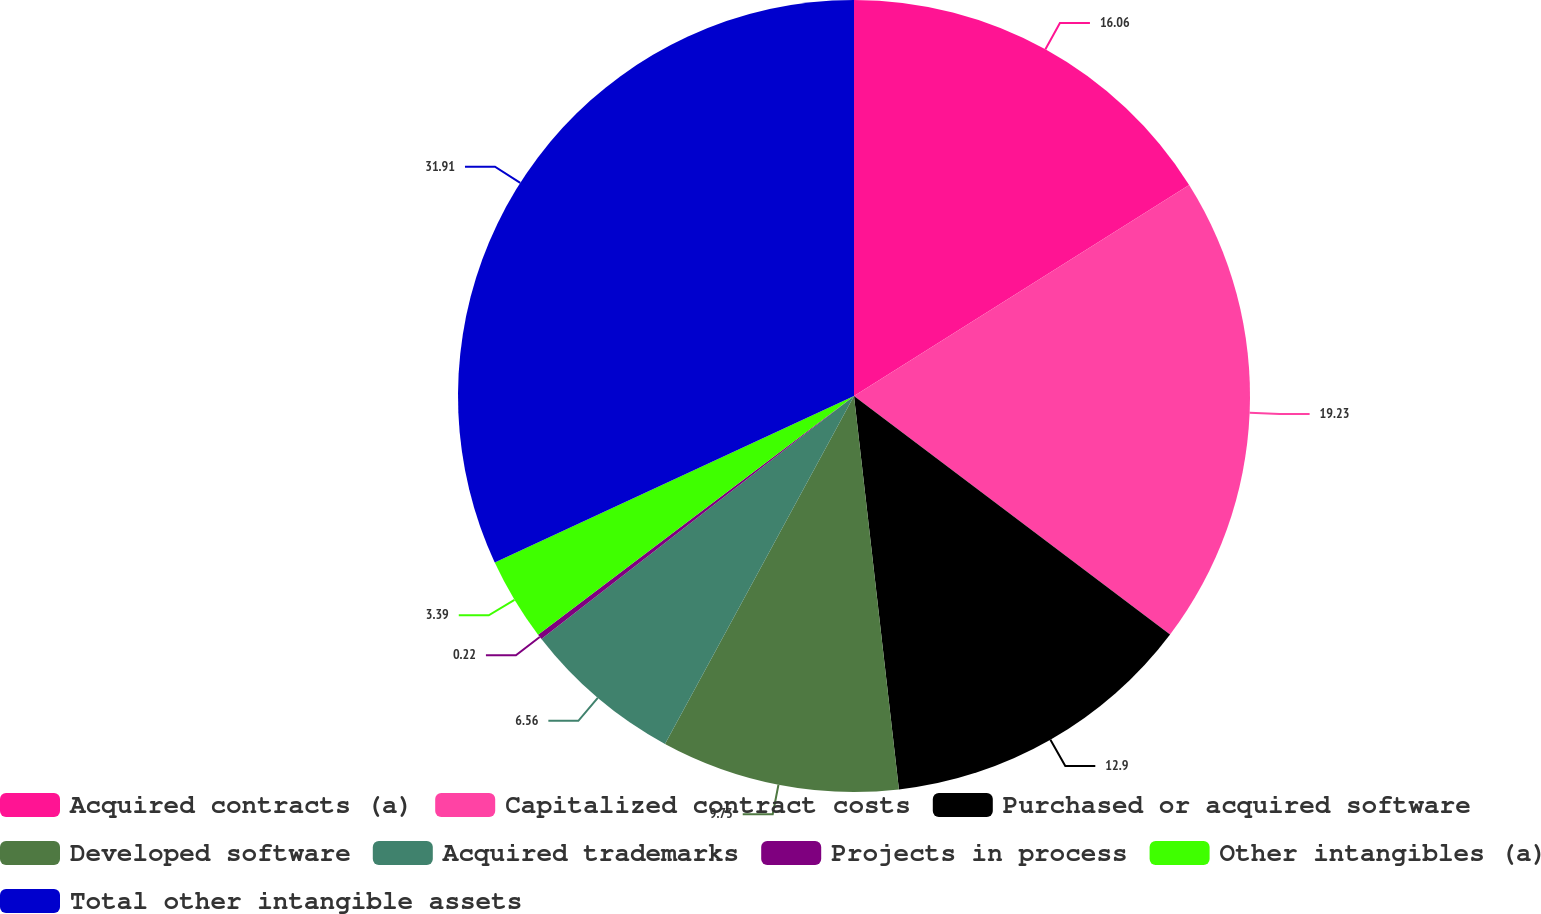Convert chart to OTSL. <chart><loc_0><loc_0><loc_500><loc_500><pie_chart><fcel>Acquired contracts (a)<fcel>Capitalized contract costs<fcel>Purchased or acquired software<fcel>Developed software<fcel>Acquired trademarks<fcel>Projects in process<fcel>Other intangibles (a)<fcel>Total other intangible assets<nl><fcel>16.06%<fcel>19.23%<fcel>12.9%<fcel>9.73%<fcel>6.56%<fcel>0.22%<fcel>3.39%<fcel>31.91%<nl></chart> 